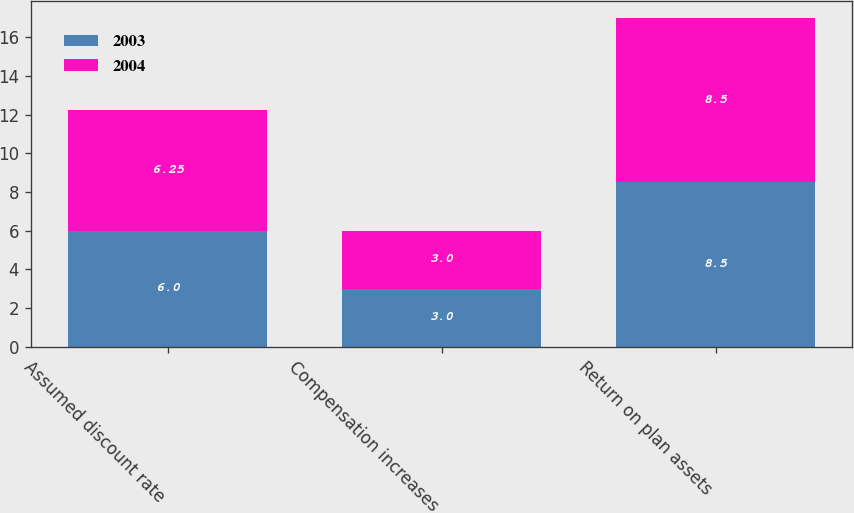Convert chart to OTSL. <chart><loc_0><loc_0><loc_500><loc_500><stacked_bar_chart><ecel><fcel>Assumed discount rate<fcel>Compensation increases<fcel>Return on plan assets<nl><fcel>2003<fcel>6<fcel>3<fcel>8.5<nl><fcel>2004<fcel>6.25<fcel>3<fcel>8.5<nl></chart> 